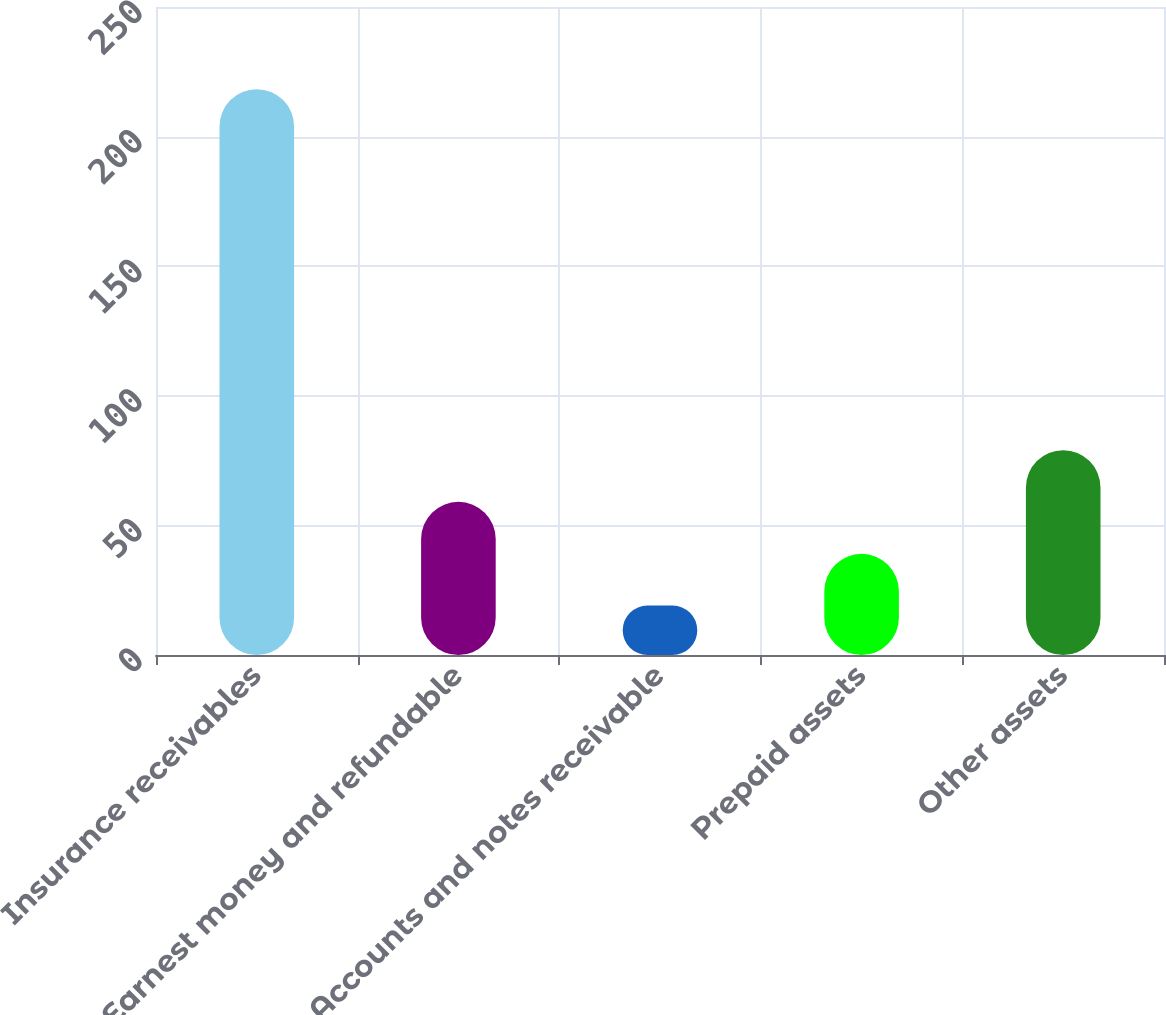Convert chart. <chart><loc_0><loc_0><loc_500><loc_500><bar_chart><fcel>Insurance receivables<fcel>Earnest money and refundable<fcel>Accounts and notes receivable<fcel>Prepaid assets<fcel>Other assets<nl><fcel>218.3<fcel>59.1<fcel>19.1<fcel>39.02<fcel>79.02<nl></chart> 